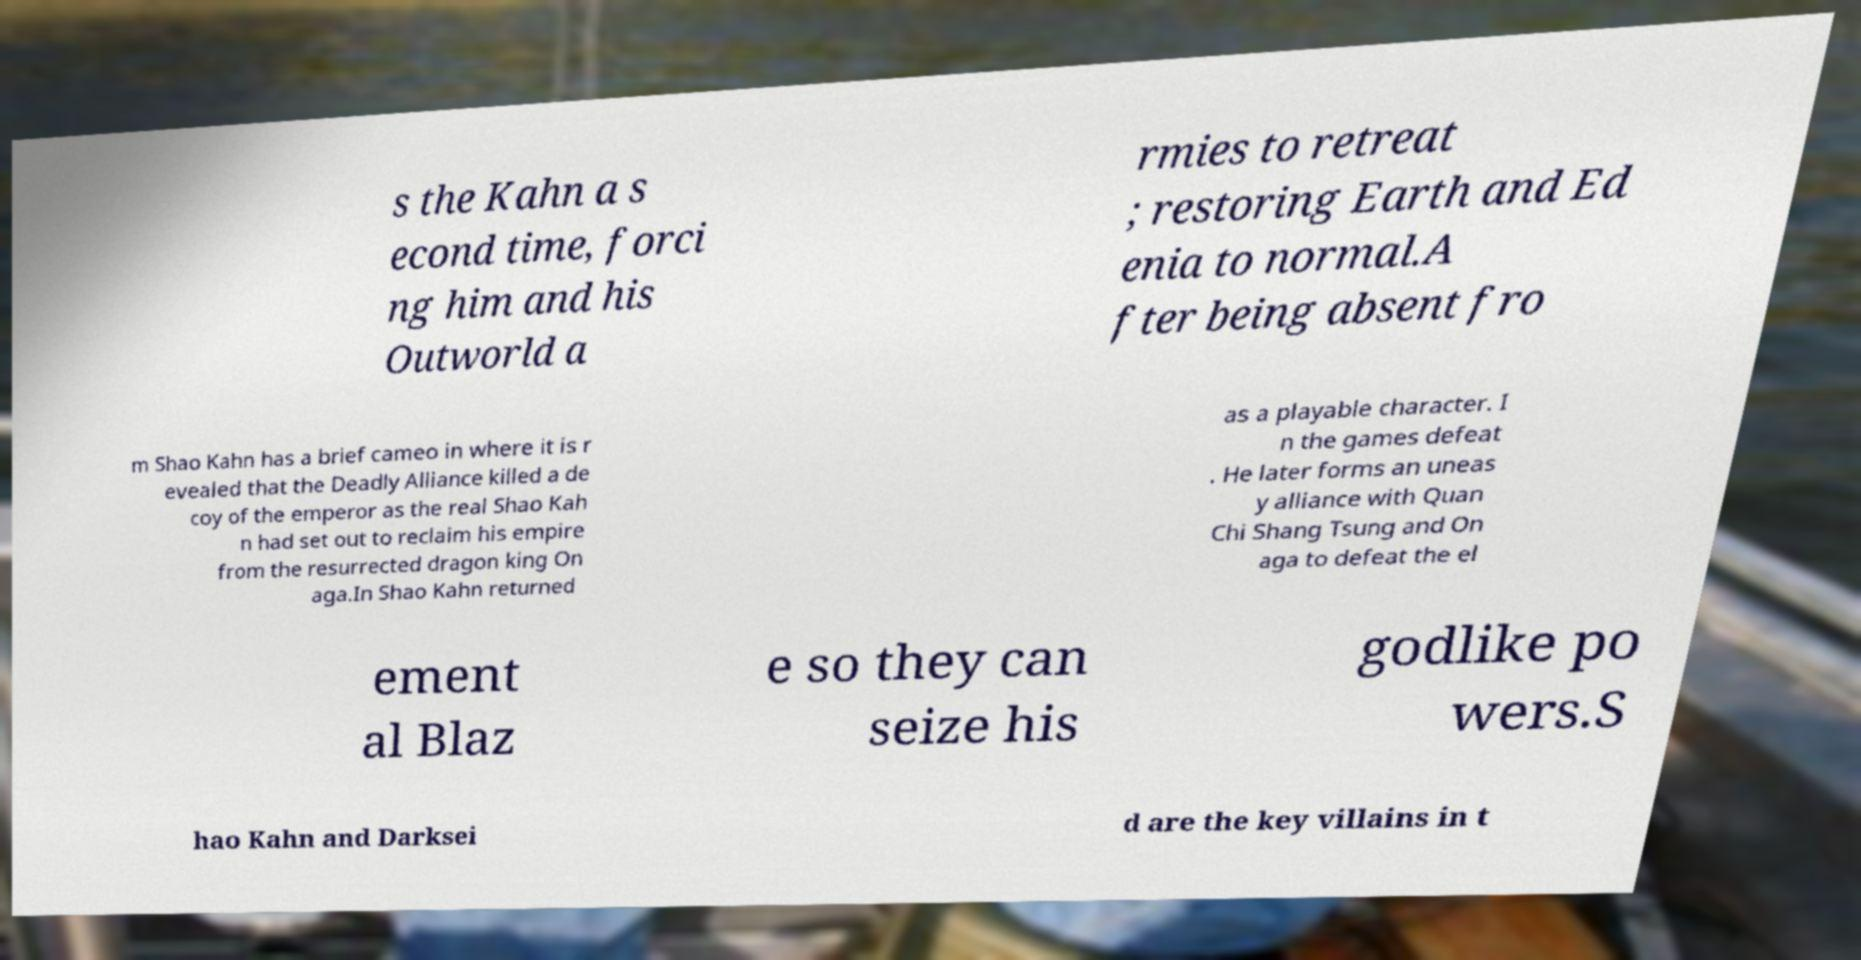Could you extract and type out the text from this image? s the Kahn a s econd time, forci ng him and his Outworld a rmies to retreat ; restoring Earth and Ed enia to normal.A fter being absent fro m Shao Kahn has a brief cameo in where it is r evealed that the Deadly Alliance killed a de coy of the emperor as the real Shao Kah n had set out to reclaim his empire from the resurrected dragon king On aga.In Shao Kahn returned as a playable character. I n the games defeat . He later forms an uneas y alliance with Quan Chi Shang Tsung and On aga to defeat the el ement al Blaz e so they can seize his godlike po wers.S hao Kahn and Darksei d are the key villains in t 